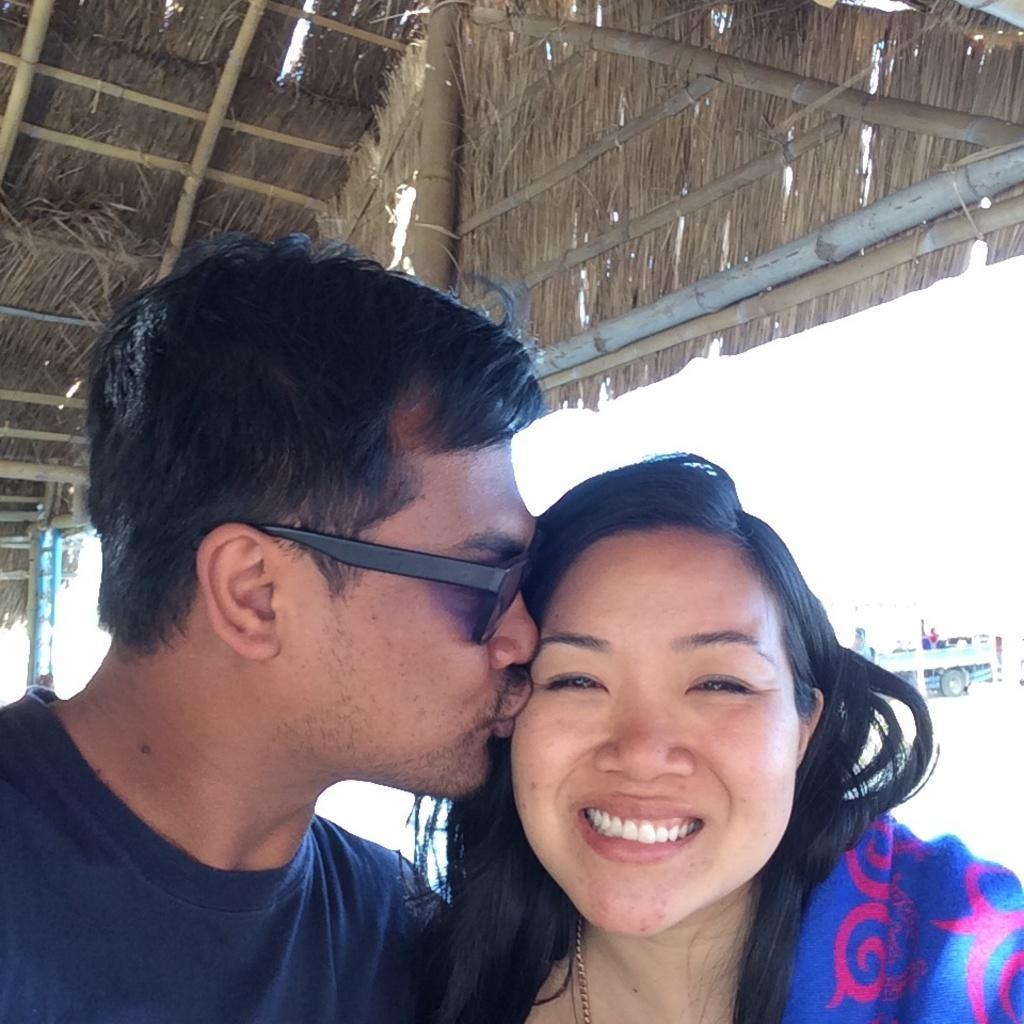Can you describe this image briefly? In this picture I can see there is a man and a woman standing here and the woman is smiling. In the backdrop there is a truck and a roof on top of them. 